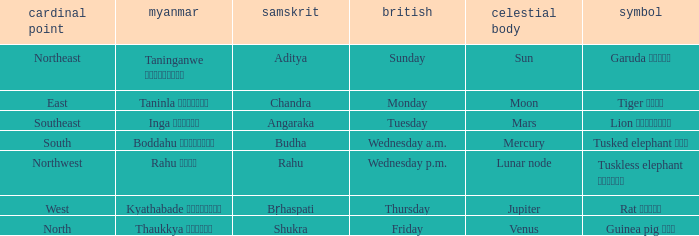What is the cardinal direction associated with Venus? North. 